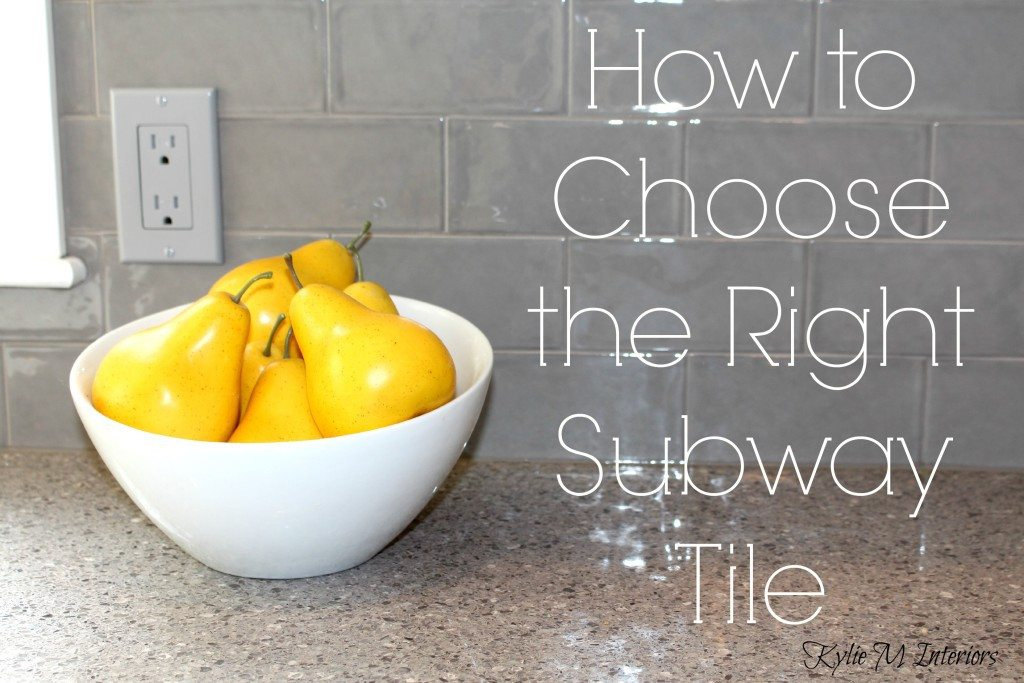Considering the glossy finish of the tiles, what specific lighting setup would optimize the reflectivity and aesthetics in this kitchen setting? To maximize the reflective properties of the glossy gray subway tiles, a combination of layered lighting sources would be ideal. Ambient lighting, such as recessed ceiling lights, offers a diffuse brightness that enhances the overall luminosity of the space without causing harsh glares. Task lighting under the cabinets provides focused illumination, important for cooking and prep areas, and can make the tiles shimmer attractively, emphasizing their texture and color. Accent lighting, possibly above the cabinets or in display areas, adds depth and highlights architectural details, creating a dynamic and visually appealing kitchen environment that complements the tiles' reflective qualities. 